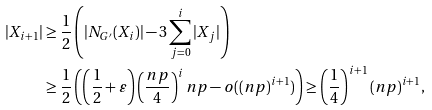Convert formula to latex. <formula><loc_0><loc_0><loc_500><loc_500>| X _ { i + 1 } | & \geq \frac { 1 } { 2 } \left ( | N _ { G ^ { \prime } } ( X _ { i } ) | - 3 \sum _ { j = 0 } ^ { i } | X _ { j } | \right ) \\ & \geq \frac { 1 } { 2 } \left ( \left ( \frac { 1 } { 2 } + \varepsilon \right ) \left ( \frac { n p } { 4 } \right ) ^ { i } n p - o ( ( n p ) ^ { i + 1 } ) \right ) \geq \left ( \frac { 1 } { 4 } \right ) ^ { i + 1 } ( n p ) ^ { i + 1 } ,</formula> 